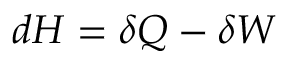Convert formula to latex. <formula><loc_0><loc_0><loc_500><loc_500>d H = \delta Q - \delta W</formula> 